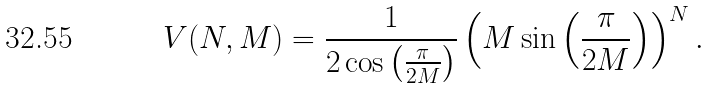Convert formula to latex. <formula><loc_0><loc_0><loc_500><loc_500>V ( N , M ) = \frac { 1 } { 2 \cos \left ( \frac { \pi } { 2 M } \right ) } \left ( M \sin \left ( \frac { \pi } { 2 M } \right ) \right ) ^ { N } .</formula> 